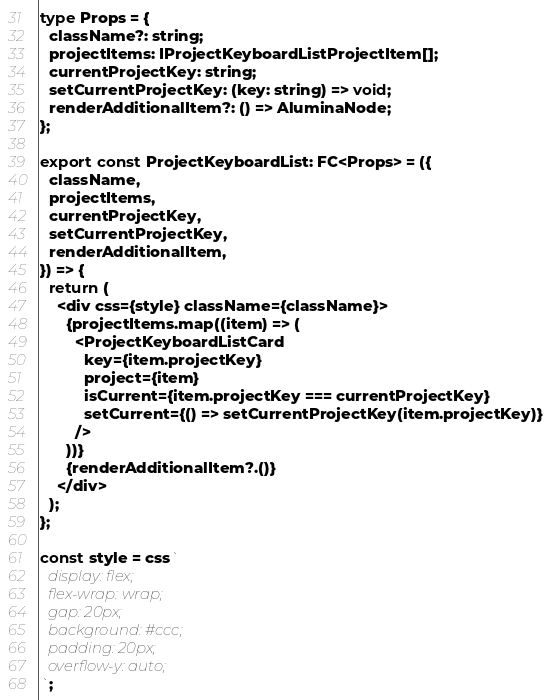Convert code to text. <code><loc_0><loc_0><loc_500><loc_500><_TypeScript_>
type Props = {
  className?: string;
  projectItems: IProjectKeyboardListProjectItem[];
  currentProjectKey: string;
  setCurrentProjectKey: (key: string) => void;
  renderAdditionalItem?: () => AluminaNode;
};

export const ProjectKeyboardList: FC<Props> = ({
  className,
  projectItems,
  currentProjectKey,
  setCurrentProjectKey,
  renderAdditionalItem,
}) => {
  return (
    <div css={style} className={className}>
      {projectItems.map((item) => (
        <ProjectKeyboardListCard
          key={item.projectKey}
          project={item}
          isCurrent={item.projectKey === currentProjectKey}
          setCurrent={() => setCurrentProjectKey(item.projectKey)}
        />
      ))}
      {renderAdditionalItem?.()}
    </div>
  );
};

const style = css`
  display: flex;
  flex-wrap: wrap;
  gap: 20px;
  background: #ccc;
  padding: 20px;
  overflow-y: auto;
`;
</code> 